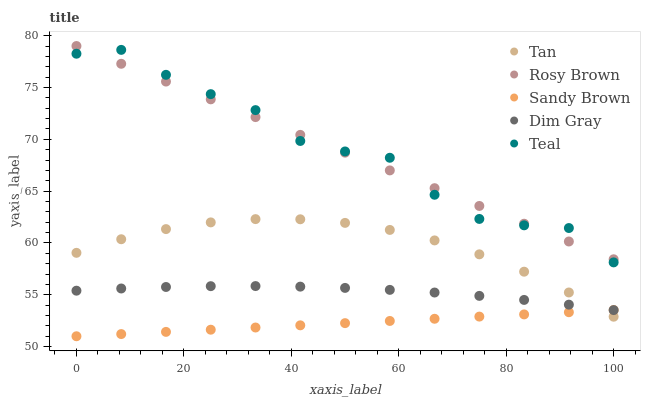Does Sandy Brown have the minimum area under the curve?
Answer yes or no. Yes. Does Teal have the maximum area under the curve?
Answer yes or no. Yes. Does Rosy Brown have the minimum area under the curve?
Answer yes or no. No. Does Rosy Brown have the maximum area under the curve?
Answer yes or no. No. Is Sandy Brown the smoothest?
Answer yes or no. Yes. Is Teal the roughest?
Answer yes or no. Yes. Is Rosy Brown the smoothest?
Answer yes or no. No. Is Rosy Brown the roughest?
Answer yes or no. No. Does Sandy Brown have the lowest value?
Answer yes or no. Yes. Does Rosy Brown have the lowest value?
Answer yes or no. No. Does Rosy Brown have the highest value?
Answer yes or no. Yes. Does Sandy Brown have the highest value?
Answer yes or no. No. Is Sandy Brown less than Rosy Brown?
Answer yes or no. Yes. Is Rosy Brown greater than Tan?
Answer yes or no. Yes. Does Tan intersect Dim Gray?
Answer yes or no. Yes. Is Tan less than Dim Gray?
Answer yes or no. No. Is Tan greater than Dim Gray?
Answer yes or no. No. Does Sandy Brown intersect Rosy Brown?
Answer yes or no. No. 